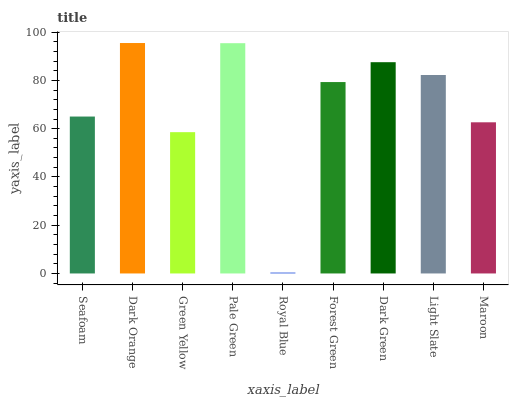Is Royal Blue the minimum?
Answer yes or no. Yes. Is Dark Orange the maximum?
Answer yes or no. Yes. Is Green Yellow the minimum?
Answer yes or no. No. Is Green Yellow the maximum?
Answer yes or no. No. Is Dark Orange greater than Green Yellow?
Answer yes or no. Yes. Is Green Yellow less than Dark Orange?
Answer yes or no. Yes. Is Green Yellow greater than Dark Orange?
Answer yes or no. No. Is Dark Orange less than Green Yellow?
Answer yes or no. No. Is Forest Green the high median?
Answer yes or no. Yes. Is Forest Green the low median?
Answer yes or no. Yes. Is Pale Green the high median?
Answer yes or no. No. Is Dark Orange the low median?
Answer yes or no. No. 